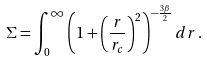<formula> <loc_0><loc_0><loc_500><loc_500>\Sigma = \int ^ { \infty } _ { 0 } \left ( 1 + \left ( \frac { r } { r _ { c } } \right ) ^ { 2 } \right ) ^ { - \frac { 3 \beta } { 2 } } d r \, .</formula> 